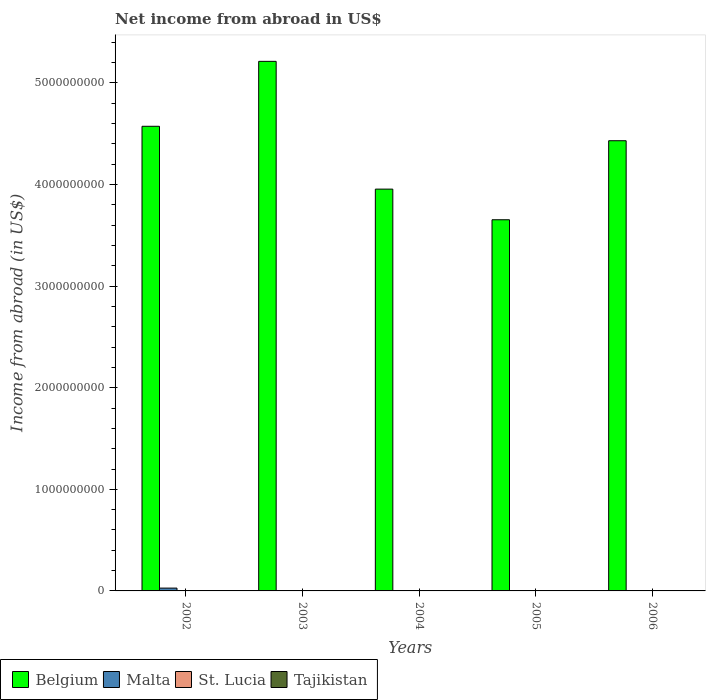Are the number of bars on each tick of the X-axis equal?
Your answer should be very brief. No. How many bars are there on the 1st tick from the left?
Keep it short and to the point. 2. How many bars are there on the 1st tick from the right?
Your answer should be compact. 1. In how many cases, is the number of bars for a given year not equal to the number of legend labels?
Give a very brief answer. 5. What is the net income from abroad in St. Lucia in 2006?
Provide a succinct answer. 0. Across all years, what is the maximum net income from abroad in Belgium?
Your response must be concise. 5.21e+09. In which year was the net income from abroad in Belgium maximum?
Provide a short and direct response. 2003. What is the total net income from abroad in St. Lucia in the graph?
Make the answer very short. 0. What is the difference between the net income from abroad in Belgium in 2004 and that in 2006?
Offer a very short reply. -4.76e+08. What is the difference between the net income from abroad in St. Lucia in 2003 and the net income from abroad in Belgium in 2004?
Provide a succinct answer. -3.96e+09. What is the average net income from abroad in Belgium per year?
Your response must be concise. 4.37e+09. What is the ratio of the net income from abroad in Belgium in 2005 to that in 2006?
Your response must be concise. 0.82. What is the difference between the highest and the second highest net income from abroad in Belgium?
Provide a succinct answer. 6.39e+08. In how many years, is the net income from abroad in Malta greater than the average net income from abroad in Malta taken over all years?
Give a very brief answer. 1. How many bars are there?
Ensure brevity in your answer.  6. Are all the bars in the graph horizontal?
Provide a succinct answer. No. How many years are there in the graph?
Make the answer very short. 5. Are the values on the major ticks of Y-axis written in scientific E-notation?
Provide a succinct answer. No. Does the graph contain grids?
Make the answer very short. No. How many legend labels are there?
Give a very brief answer. 4. How are the legend labels stacked?
Your answer should be compact. Horizontal. What is the title of the graph?
Provide a short and direct response. Net income from abroad in US$. What is the label or title of the X-axis?
Your response must be concise. Years. What is the label or title of the Y-axis?
Your answer should be compact. Income from abroad (in US$). What is the Income from abroad (in US$) of Belgium in 2002?
Offer a very short reply. 4.57e+09. What is the Income from abroad (in US$) of Malta in 2002?
Ensure brevity in your answer.  2.77e+07. What is the Income from abroad (in US$) of Belgium in 2003?
Keep it short and to the point. 5.21e+09. What is the Income from abroad (in US$) of Belgium in 2004?
Provide a short and direct response. 3.96e+09. What is the Income from abroad (in US$) of Malta in 2004?
Ensure brevity in your answer.  0. What is the Income from abroad (in US$) of Tajikistan in 2004?
Offer a terse response. 0. What is the Income from abroad (in US$) in Belgium in 2005?
Offer a terse response. 3.65e+09. What is the Income from abroad (in US$) in Malta in 2005?
Offer a terse response. 0. What is the Income from abroad (in US$) in St. Lucia in 2005?
Keep it short and to the point. 0. What is the Income from abroad (in US$) of Belgium in 2006?
Provide a succinct answer. 4.43e+09. What is the Income from abroad (in US$) in St. Lucia in 2006?
Your answer should be very brief. 0. What is the Income from abroad (in US$) of Tajikistan in 2006?
Your answer should be very brief. 0. Across all years, what is the maximum Income from abroad (in US$) in Belgium?
Make the answer very short. 5.21e+09. Across all years, what is the maximum Income from abroad (in US$) in Malta?
Give a very brief answer. 2.77e+07. Across all years, what is the minimum Income from abroad (in US$) in Belgium?
Give a very brief answer. 3.65e+09. What is the total Income from abroad (in US$) of Belgium in the graph?
Your answer should be very brief. 2.18e+1. What is the total Income from abroad (in US$) of Malta in the graph?
Your response must be concise. 2.77e+07. What is the difference between the Income from abroad (in US$) in Belgium in 2002 and that in 2003?
Make the answer very short. -6.39e+08. What is the difference between the Income from abroad (in US$) in Belgium in 2002 and that in 2004?
Your answer should be very brief. 6.18e+08. What is the difference between the Income from abroad (in US$) in Belgium in 2002 and that in 2005?
Offer a terse response. 9.20e+08. What is the difference between the Income from abroad (in US$) of Belgium in 2002 and that in 2006?
Your response must be concise. 1.42e+08. What is the difference between the Income from abroad (in US$) of Belgium in 2003 and that in 2004?
Provide a succinct answer. 1.26e+09. What is the difference between the Income from abroad (in US$) in Belgium in 2003 and that in 2005?
Offer a terse response. 1.56e+09. What is the difference between the Income from abroad (in US$) in Belgium in 2003 and that in 2006?
Provide a short and direct response. 7.81e+08. What is the difference between the Income from abroad (in US$) in Belgium in 2004 and that in 2005?
Offer a terse response. 3.02e+08. What is the difference between the Income from abroad (in US$) in Belgium in 2004 and that in 2006?
Offer a terse response. -4.76e+08. What is the difference between the Income from abroad (in US$) in Belgium in 2005 and that in 2006?
Your response must be concise. -7.78e+08. What is the average Income from abroad (in US$) of Belgium per year?
Your answer should be compact. 4.37e+09. What is the average Income from abroad (in US$) of Malta per year?
Offer a very short reply. 5.54e+06. What is the average Income from abroad (in US$) in St. Lucia per year?
Provide a succinct answer. 0. In the year 2002, what is the difference between the Income from abroad (in US$) of Belgium and Income from abroad (in US$) of Malta?
Make the answer very short. 4.55e+09. What is the ratio of the Income from abroad (in US$) in Belgium in 2002 to that in 2003?
Your answer should be compact. 0.88. What is the ratio of the Income from abroad (in US$) in Belgium in 2002 to that in 2004?
Give a very brief answer. 1.16. What is the ratio of the Income from abroad (in US$) in Belgium in 2002 to that in 2005?
Keep it short and to the point. 1.25. What is the ratio of the Income from abroad (in US$) in Belgium in 2002 to that in 2006?
Your answer should be compact. 1.03. What is the ratio of the Income from abroad (in US$) of Belgium in 2003 to that in 2004?
Keep it short and to the point. 1.32. What is the ratio of the Income from abroad (in US$) in Belgium in 2003 to that in 2005?
Your answer should be very brief. 1.43. What is the ratio of the Income from abroad (in US$) in Belgium in 2003 to that in 2006?
Provide a short and direct response. 1.18. What is the ratio of the Income from abroad (in US$) of Belgium in 2004 to that in 2005?
Your answer should be very brief. 1.08. What is the ratio of the Income from abroad (in US$) in Belgium in 2004 to that in 2006?
Ensure brevity in your answer.  0.89. What is the ratio of the Income from abroad (in US$) in Belgium in 2005 to that in 2006?
Provide a short and direct response. 0.82. What is the difference between the highest and the second highest Income from abroad (in US$) of Belgium?
Make the answer very short. 6.39e+08. What is the difference between the highest and the lowest Income from abroad (in US$) in Belgium?
Your answer should be compact. 1.56e+09. What is the difference between the highest and the lowest Income from abroad (in US$) in Malta?
Make the answer very short. 2.77e+07. 